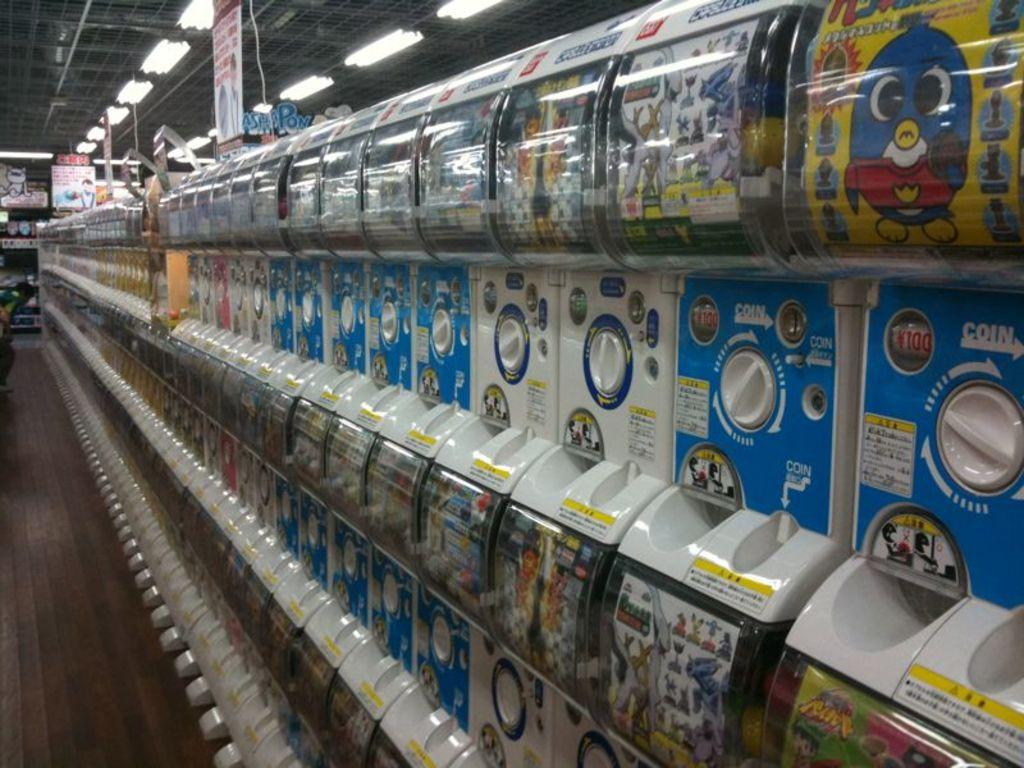<image>
Render a clear and concise summary of the photo. A row of vending machines that say COIN on them. 